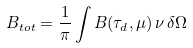<formula> <loc_0><loc_0><loc_500><loc_500>B _ { t o t } = \frac { 1 } { \pi } \int B ( \tau _ { d } , \mu ) \, \nu \, \delta \Omega</formula> 